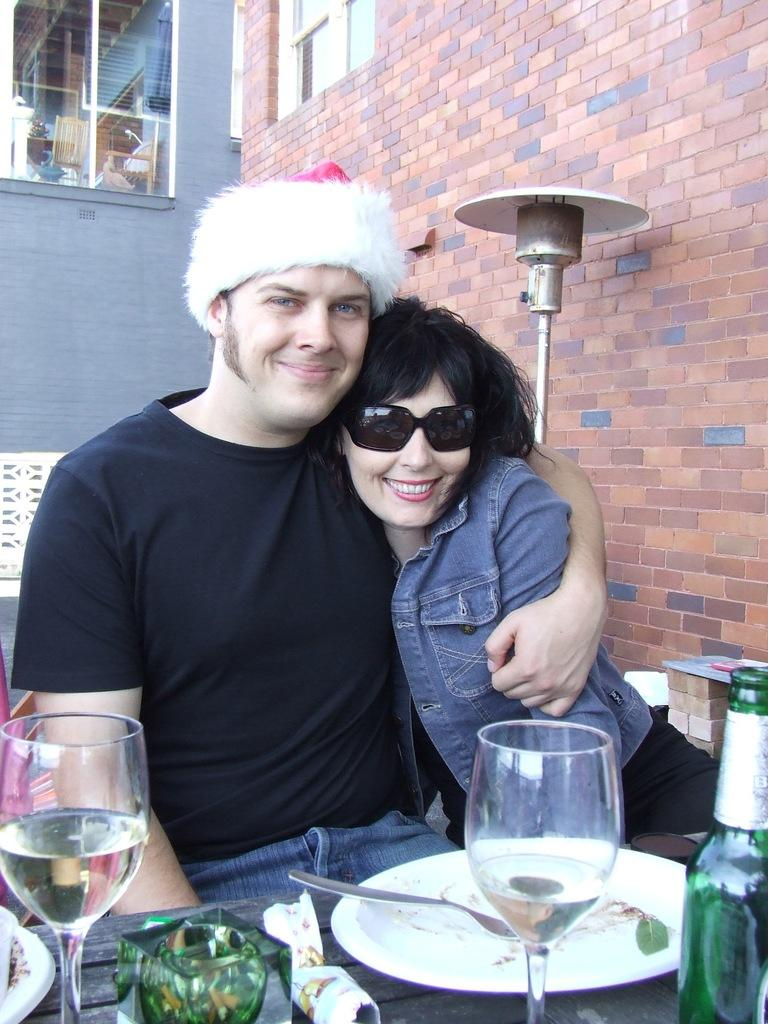How many people are in the image? There are two persons in the image. Where are the persons located in relation to the wall? The persons are sitting beside a wall. What is in front of the persons? The persons are in front of a table. What items can be seen on the table? The table contains glasses, a plate, and a bottle. What is visible at the top of the image? There is a window at the top of the image. What type of books are the persons reading in the image? There are no books present in the image. What part of the wrist is visible in the image? There is no visible wrist in the image. 